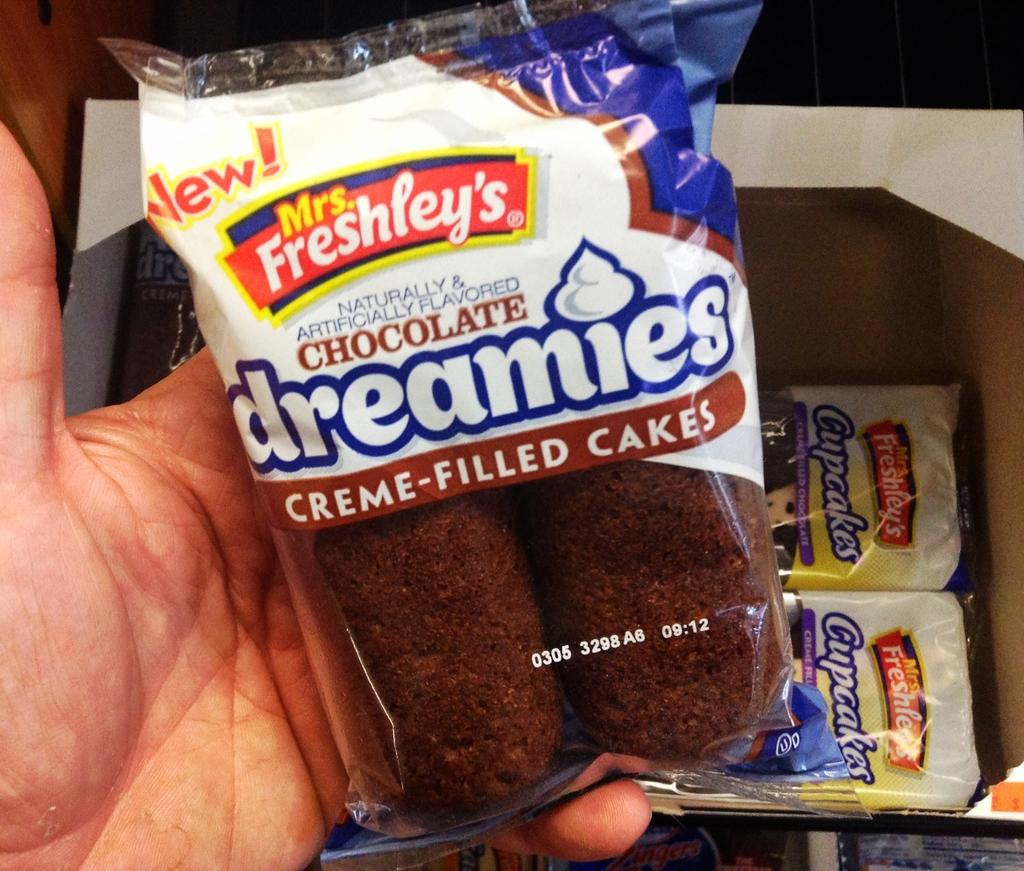<image>
Render a clear and concise summary of the photo. A package of Mrs. Frehsley's Chocolate Dreamies Creme-Filled Cakes 